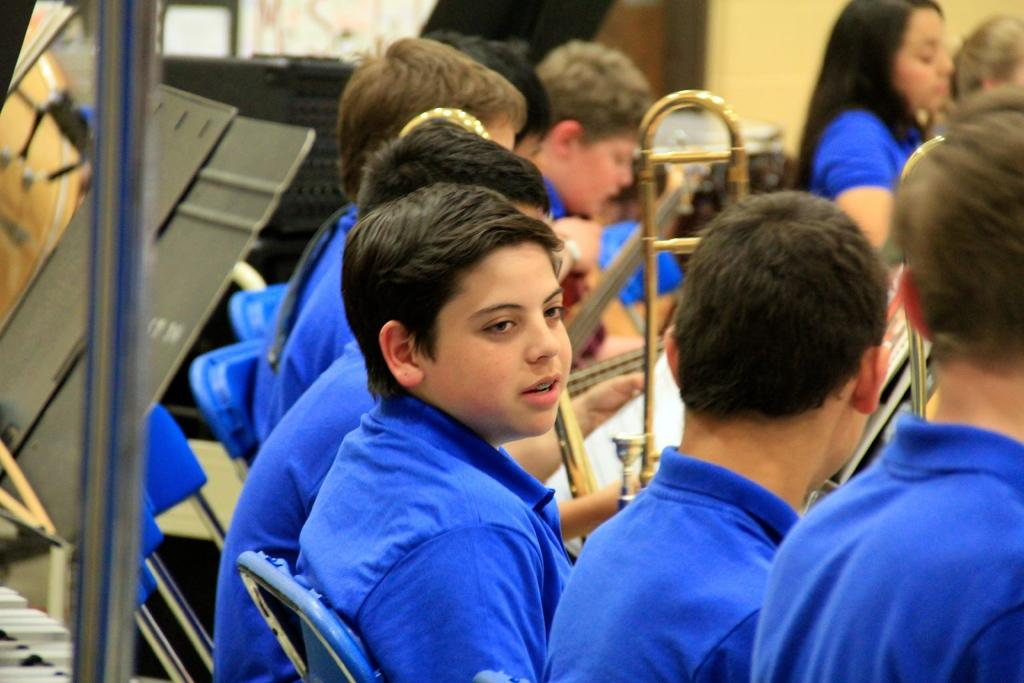What types of people are in the image? There are boys and girls in the image. What are the children doing in the image? The children are sitting on chairs. What can be seen in the top right corner of the image? There is a wall visible in the top right of the image. What is to the left of the children? There is a metal rod to the left of the children. What is behind the metal rod? There are a few objects behind the metal rod. What type of ornament is hanging from the sidewalk in the image? There is no sidewalk or ornament present in the image. 